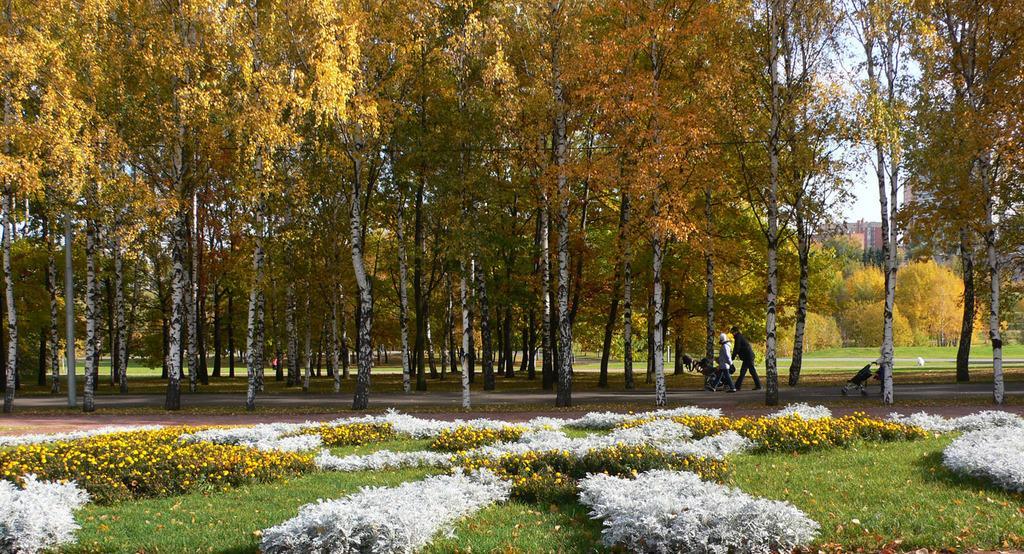Could you give a brief overview of what you see in this image? In the picture we can see a garden with a grass surface on it, we can see small plants which are white in color and some plants with yellow colored flowers and behind it, we can see a path to it, we can see a two people are walking holding a cart and behind them also we can see one person is walking with a cart and besides them we can see trees and in the background also we can see trees, building and a part of the sky. 